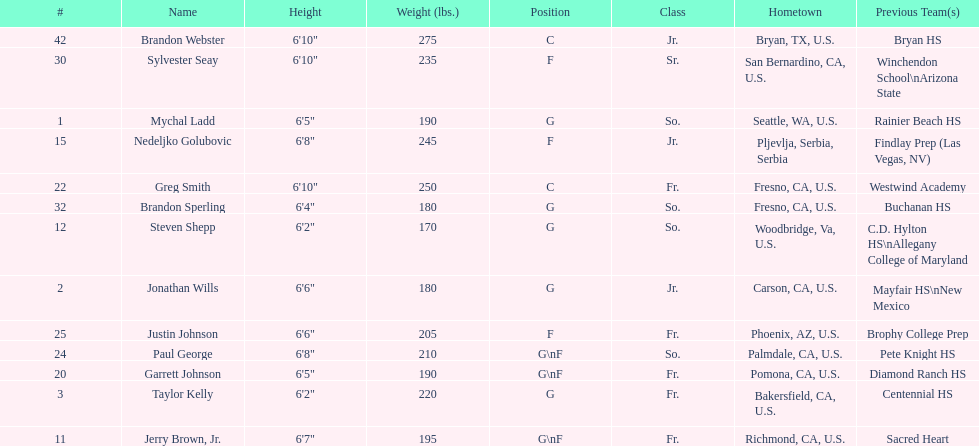How many players and both guard (g) and forward (f)? 3. 